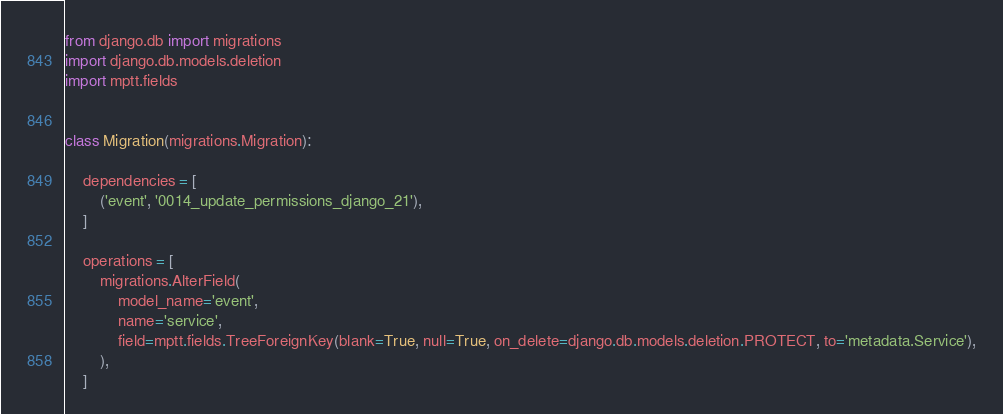<code> <loc_0><loc_0><loc_500><loc_500><_Python_>from django.db import migrations
import django.db.models.deletion
import mptt.fields


class Migration(migrations.Migration):

    dependencies = [
        ('event', '0014_update_permissions_django_21'),
    ]

    operations = [
        migrations.AlterField(
            model_name='event',
            name='service',
            field=mptt.fields.TreeForeignKey(blank=True, null=True, on_delete=django.db.models.deletion.PROTECT, to='metadata.Service'),
        ),
    ]
</code> 